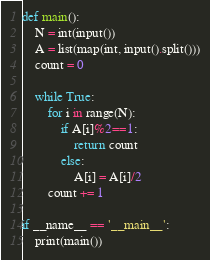<code> <loc_0><loc_0><loc_500><loc_500><_Python_>def main():
    N = int(input())
    A = list(map(int, input().split()))
    count = 0

    while True:
        for i in range(N):
            if A[i]%2==1:
                return count
            else:
                A[i] = A[i]/2
        count += 1

if __name__ == '__main__':
    print(main())</code> 